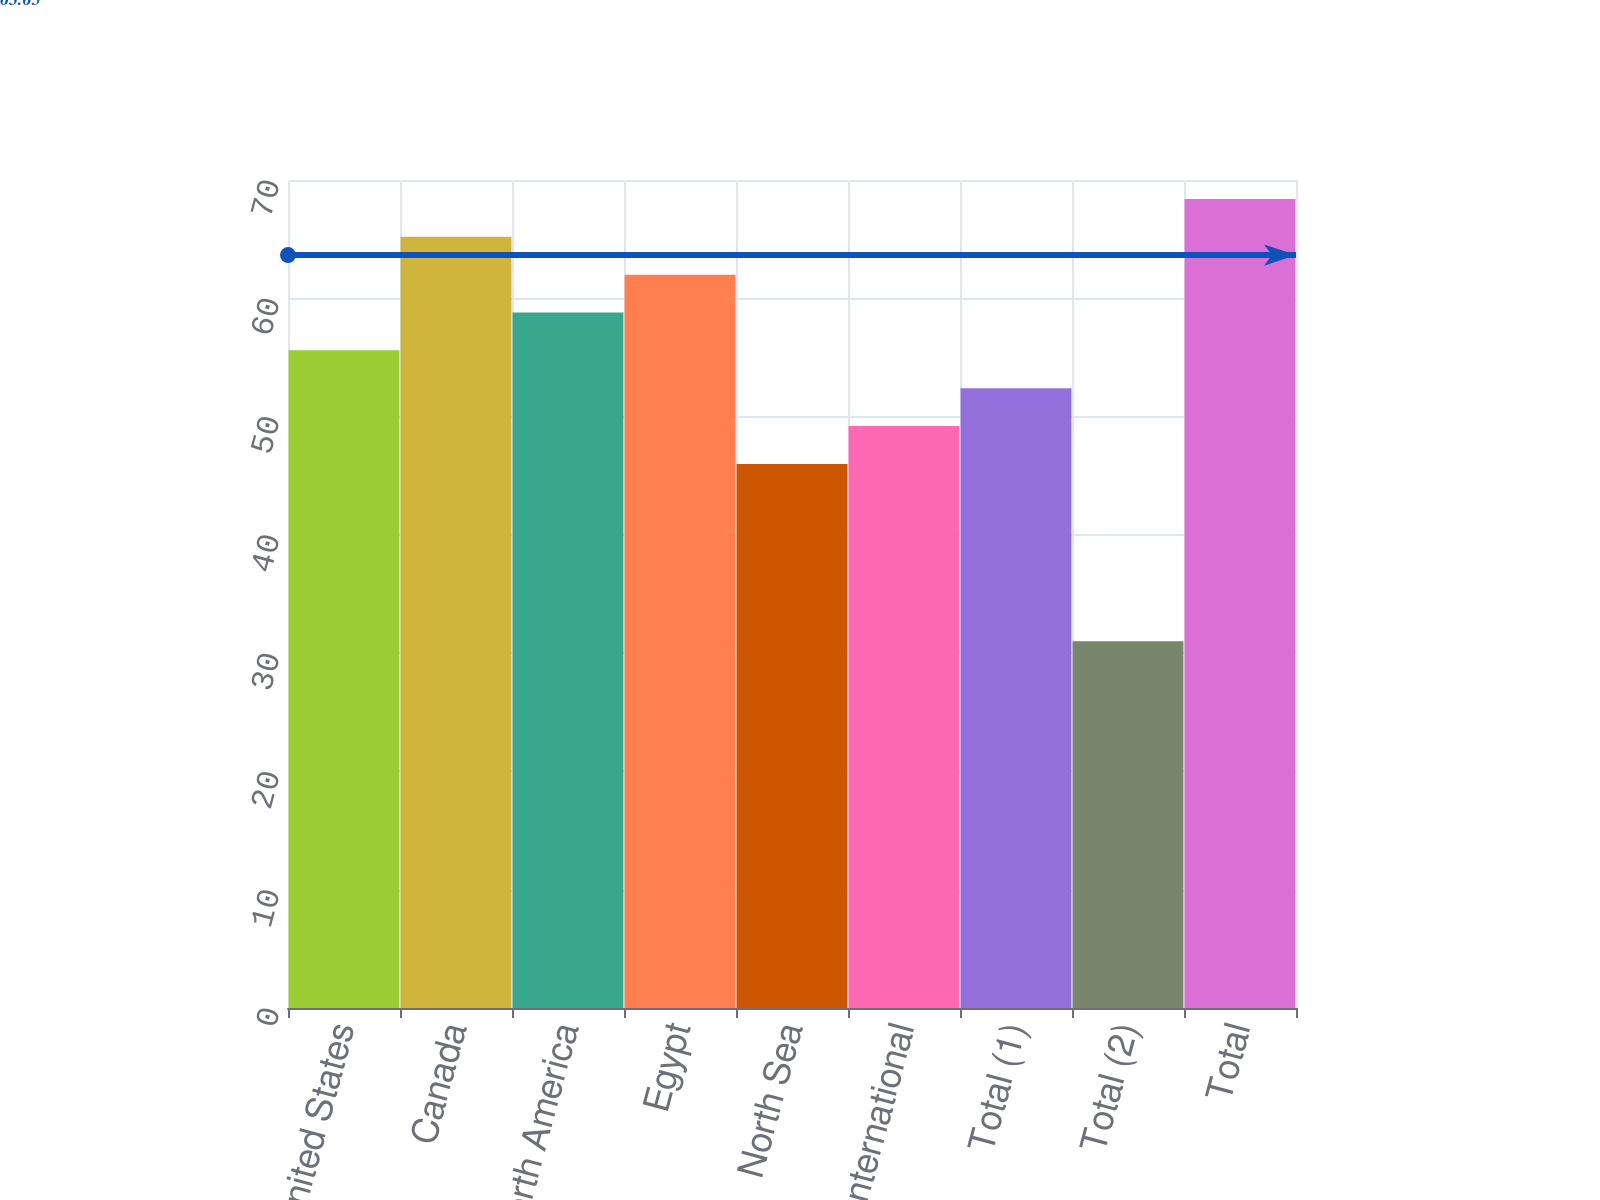Convert chart to OTSL. <chart><loc_0><loc_0><loc_500><loc_500><bar_chart><fcel>United States<fcel>Canada<fcel>North America<fcel>Egypt<fcel>North Sea<fcel>International<fcel>Total (1)<fcel>Total (2)<fcel>Total<nl><fcel>55.6<fcel>65.2<fcel>58.8<fcel>62<fcel>46<fcel>49.2<fcel>52.4<fcel>31<fcel>68.4<nl></chart> 